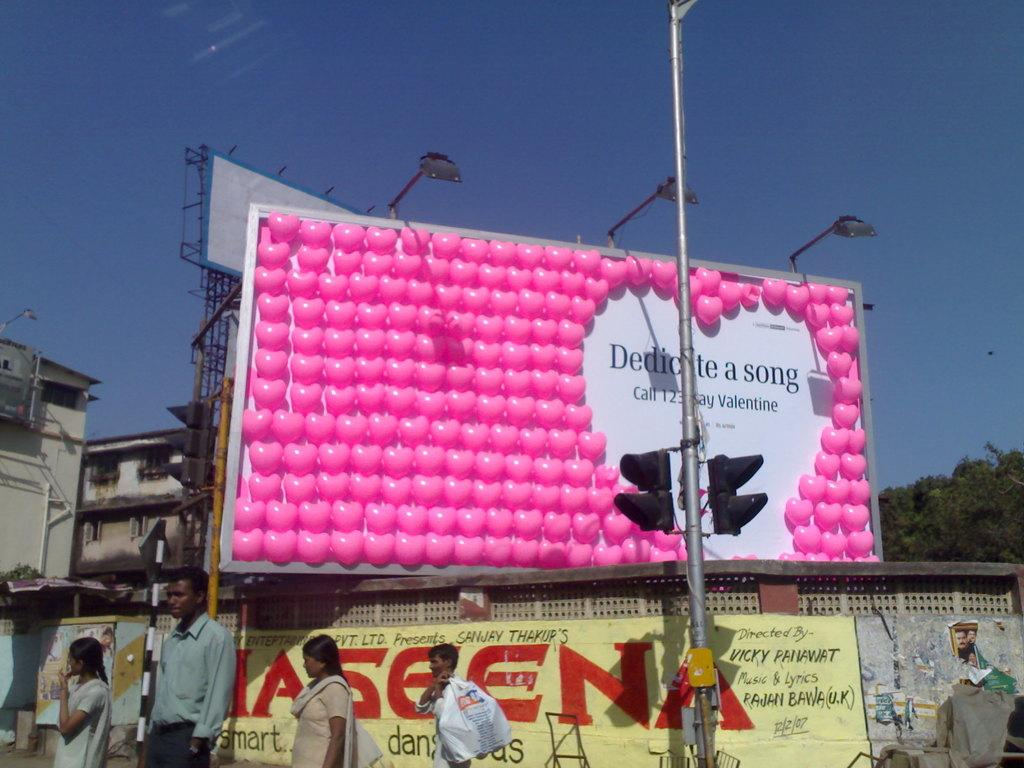<image>
Relay a brief, clear account of the picture shown. A billboard is advertising a Valentine's day special using balloons. 